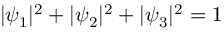<formula> <loc_0><loc_0><loc_500><loc_500>| \psi _ { 1 } | ^ { 2 } + | \psi _ { 2 } | ^ { 2 } + | \psi _ { 3 } | ^ { 2 } = 1</formula> 